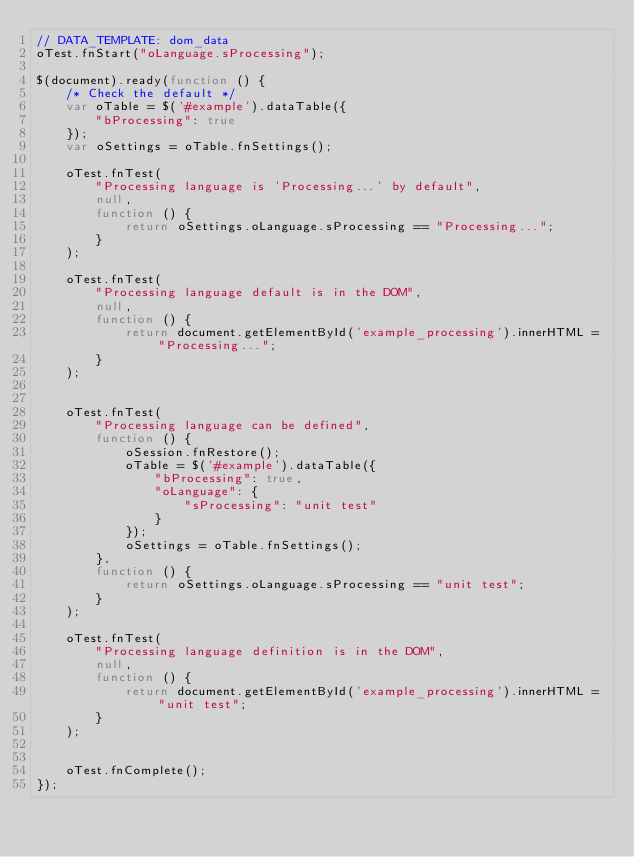<code> <loc_0><loc_0><loc_500><loc_500><_JavaScript_>// DATA_TEMPLATE: dom_data
oTest.fnStart("oLanguage.sProcessing");

$(document).ready(function () {
    /* Check the default */
    var oTable = $('#example').dataTable({
        "bProcessing": true
    });
    var oSettings = oTable.fnSettings();

    oTest.fnTest(
        "Processing language is 'Processing...' by default",
        null,
        function () {
            return oSettings.oLanguage.sProcessing == "Processing...";
        }
    );

    oTest.fnTest(
        "Processing language default is in the DOM",
        null,
        function () {
            return document.getElementById('example_processing').innerHTML = "Processing...";
        }
    );


    oTest.fnTest(
        "Processing language can be defined",
        function () {
            oSession.fnRestore();
            oTable = $('#example').dataTable({
                "bProcessing": true,
                "oLanguage": {
                    "sProcessing": "unit test"
                }
            });
            oSettings = oTable.fnSettings();
        },
        function () {
            return oSettings.oLanguage.sProcessing == "unit test";
        }
    );

    oTest.fnTest(
        "Processing language definition is in the DOM",
        null,
        function () {
            return document.getElementById('example_processing').innerHTML = "unit test";
        }
    );


    oTest.fnComplete();
});</code> 